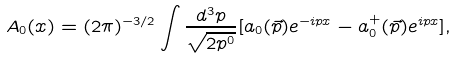Convert formula to latex. <formula><loc_0><loc_0><loc_500><loc_500>A _ { 0 } ( x ) = ( 2 \pi ) ^ { - 3 / 2 } \int \frac { d ^ { 3 } p } { \sqrt { 2 p ^ { 0 } } } [ a _ { 0 } ( \vec { p } ) e ^ { - i p x } - a _ { 0 } ^ { + } ( \vec { p } ) e ^ { i p x } ] ,</formula> 